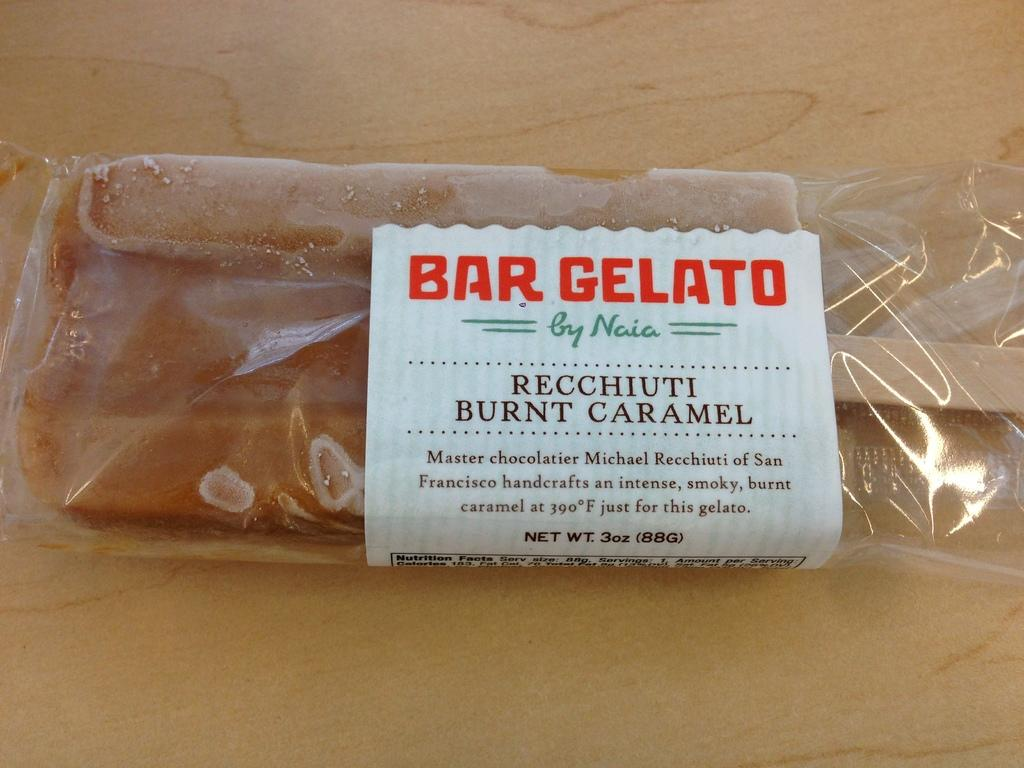What is the main subject of the image? The main subject of the image is an ice cream. How is the ice cream being stored or protected in the image? The ice cream is covered in the image. What else can be seen in the image besides the ice cream? There is a paper with writing and a wooden surface present in the image. Can you tell me how many cherries are on top of the ice cream in the image? There are no cherries visible on top of the ice cream in the image. What type of cooking technique is being demonstrated in the image? There is no cooking technique being demonstrated in the image; it primarily features an ice cream that is covered. 